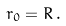<formula> <loc_0><loc_0><loc_500><loc_500>r _ { 0 } = R \, .</formula> 